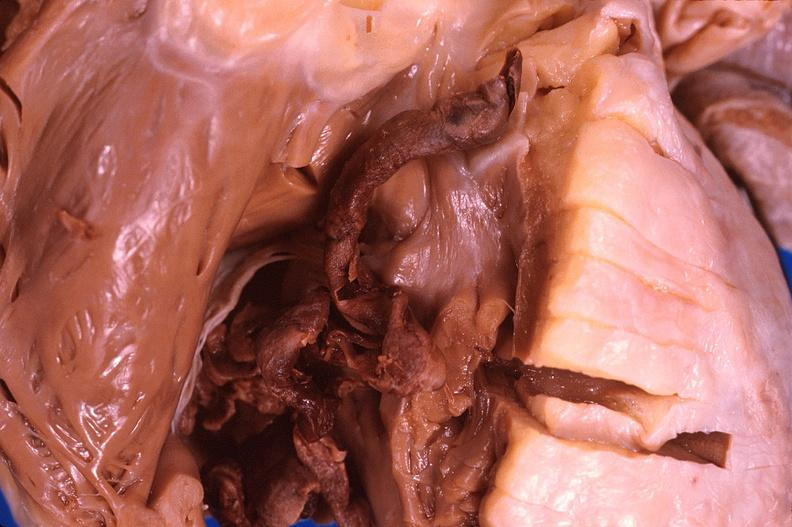s heart present?
Answer the question using a single word or phrase. Yes 